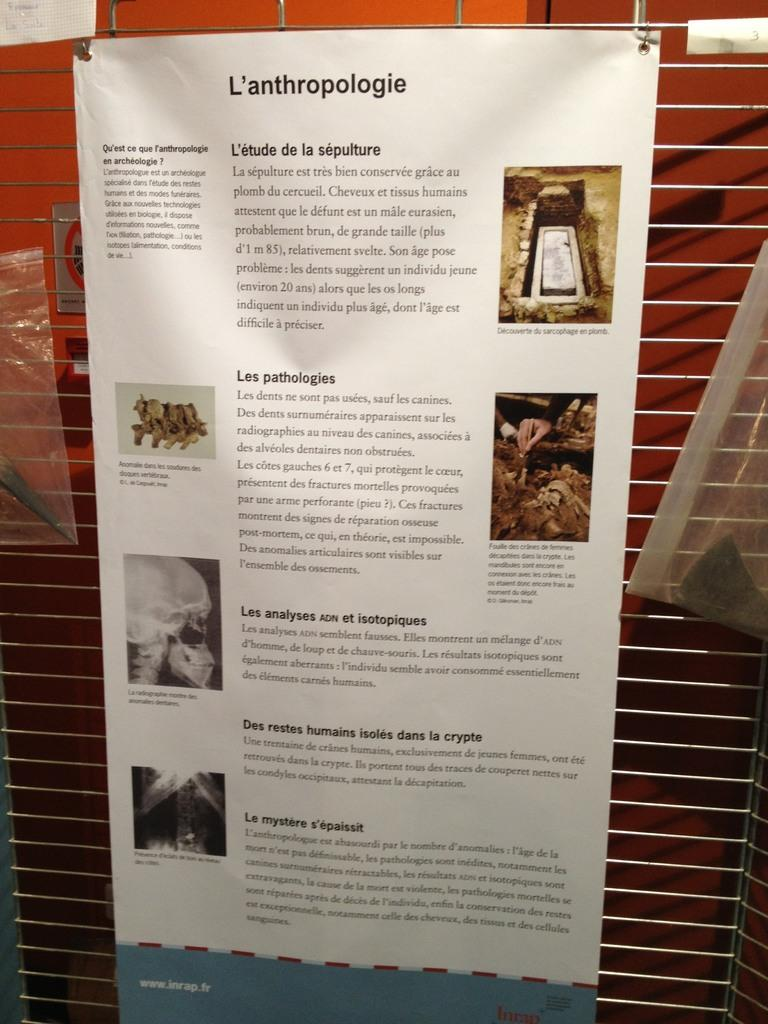<image>
Provide a brief description of the given image. A poster on a wall is titled L'anthropologie and has pictures and text on it. 